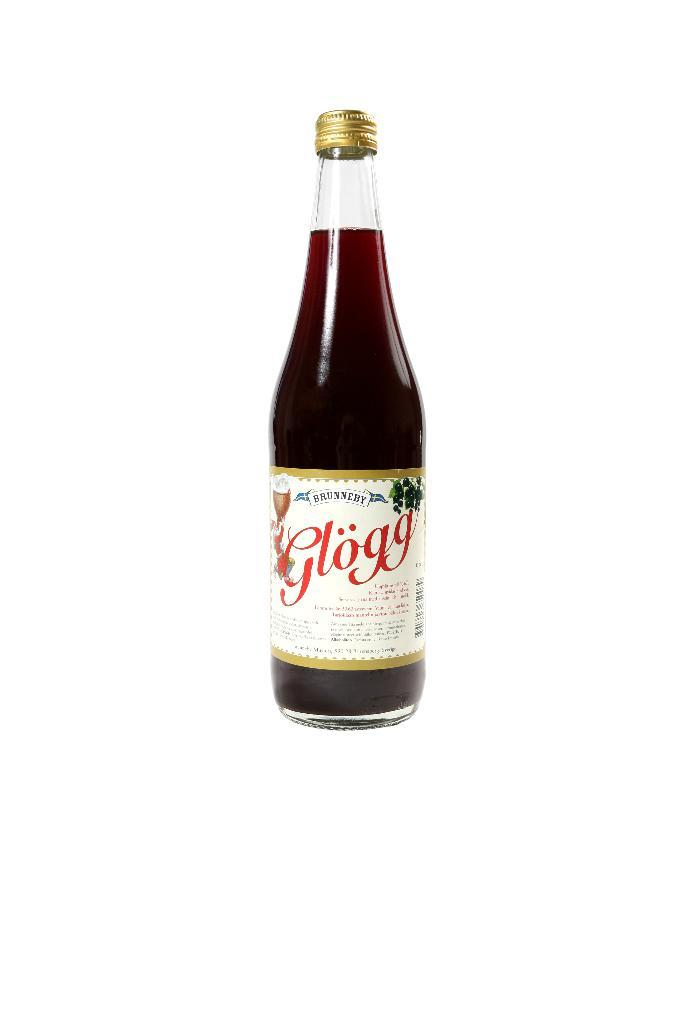What is the main object visible in the image? There is a juice bottle in the image. What type of grain is stored in the sack next to the juice bottle in the image? There is no sack or grain present in the image; it only features a juice bottle. 